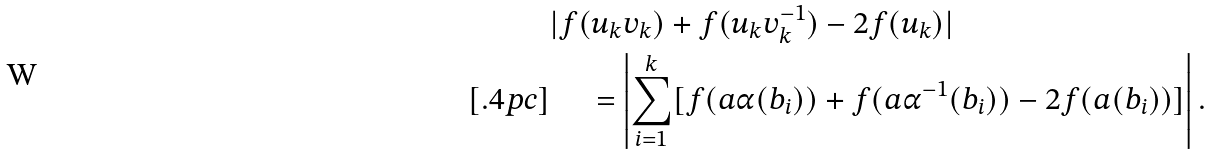<formula> <loc_0><loc_0><loc_500><loc_500>& | f ( u _ { k } v _ { k } ) + f ( u _ { k } v _ { k } ^ { - 1 } ) - 2 f ( u _ { k } ) | \\ [ . 4 p c ] & \quad \, = \left | \sum _ { i = 1 } ^ { k } [ f ( a \alpha ( b _ { i } ) ) + f ( a \alpha ^ { - 1 } ( b _ { i } ) ) - 2 f ( a ( b _ { i } ) ) ] \right | .</formula> 